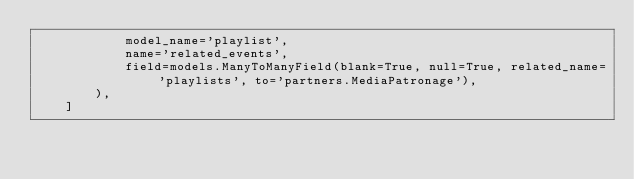Convert code to text. <code><loc_0><loc_0><loc_500><loc_500><_Python_>            model_name='playlist',
            name='related_events',
            field=models.ManyToManyField(blank=True, null=True, related_name='playlists', to='partners.MediaPatronage'),
        ),
    ]
</code> 